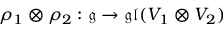<formula> <loc_0><loc_0><loc_500><loc_500>\rho _ { 1 } \otimes \rho _ { 2 } \colon { \mathfrak { g } } \rightarrow { \mathfrak { g l } } ( V _ { 1 } \otimes V _ { 2 } )</formula> 